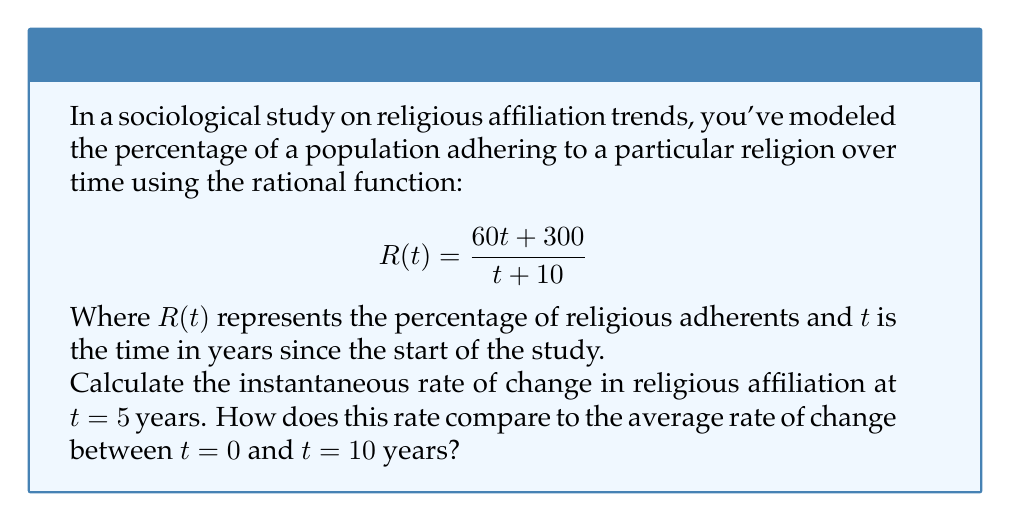Can you answer this question? 1) To find the instantaneous rate of change at $t = 5$, we need to calculate the derivative of $R(t)$ and evaluate it at $t = 5$.

2) Using the quotient rule to find $R'(t)$:
   $$R'(t) = \frac{(t+10)(60) - (60t+300)(1)}{(t+10)^2}$$
   $$R'(t) = \frac{60t + 600 - 60t - 300}{(t+10)^2}$$
   $$R'(t) = \frac{300}{(t+10)^2}$$

3) Evaluating $R'(5)$:
   $$R'(5) = \frac{300}{(5+10)^2} = \frac{300}{225} = \frac{4}{3} \approx 1.33$$

4) For the average rate of change between $t = 0$ and $t = 10$:
   $$\text{Average Rate} = \frac{R(10) - R(0)}{10 - 0}$$

5) Calculate $R(0)$ and $R(10)$:
   $$R(0) = \frac{60(0) + 300}{0 + 10} = 30$$
   $$R(10) = \frac{60(10) + 300}{10 + 10} = 45$$

6) Now calculate the average rate:
   $$\text{Average Rate} = \frac{45 - 30}{10} = 1.5$$

7) Compare: The instantaneous rate at $t = 5$ (1.33) is slightly lower than the average rate between $t = 0$ and $t = 10$ (1.5).
Answer: Instantaneous rate at $t=5$: $\frac{4}{3}$; Average rate from $t=0$ to $t=10$: $1.5$ 